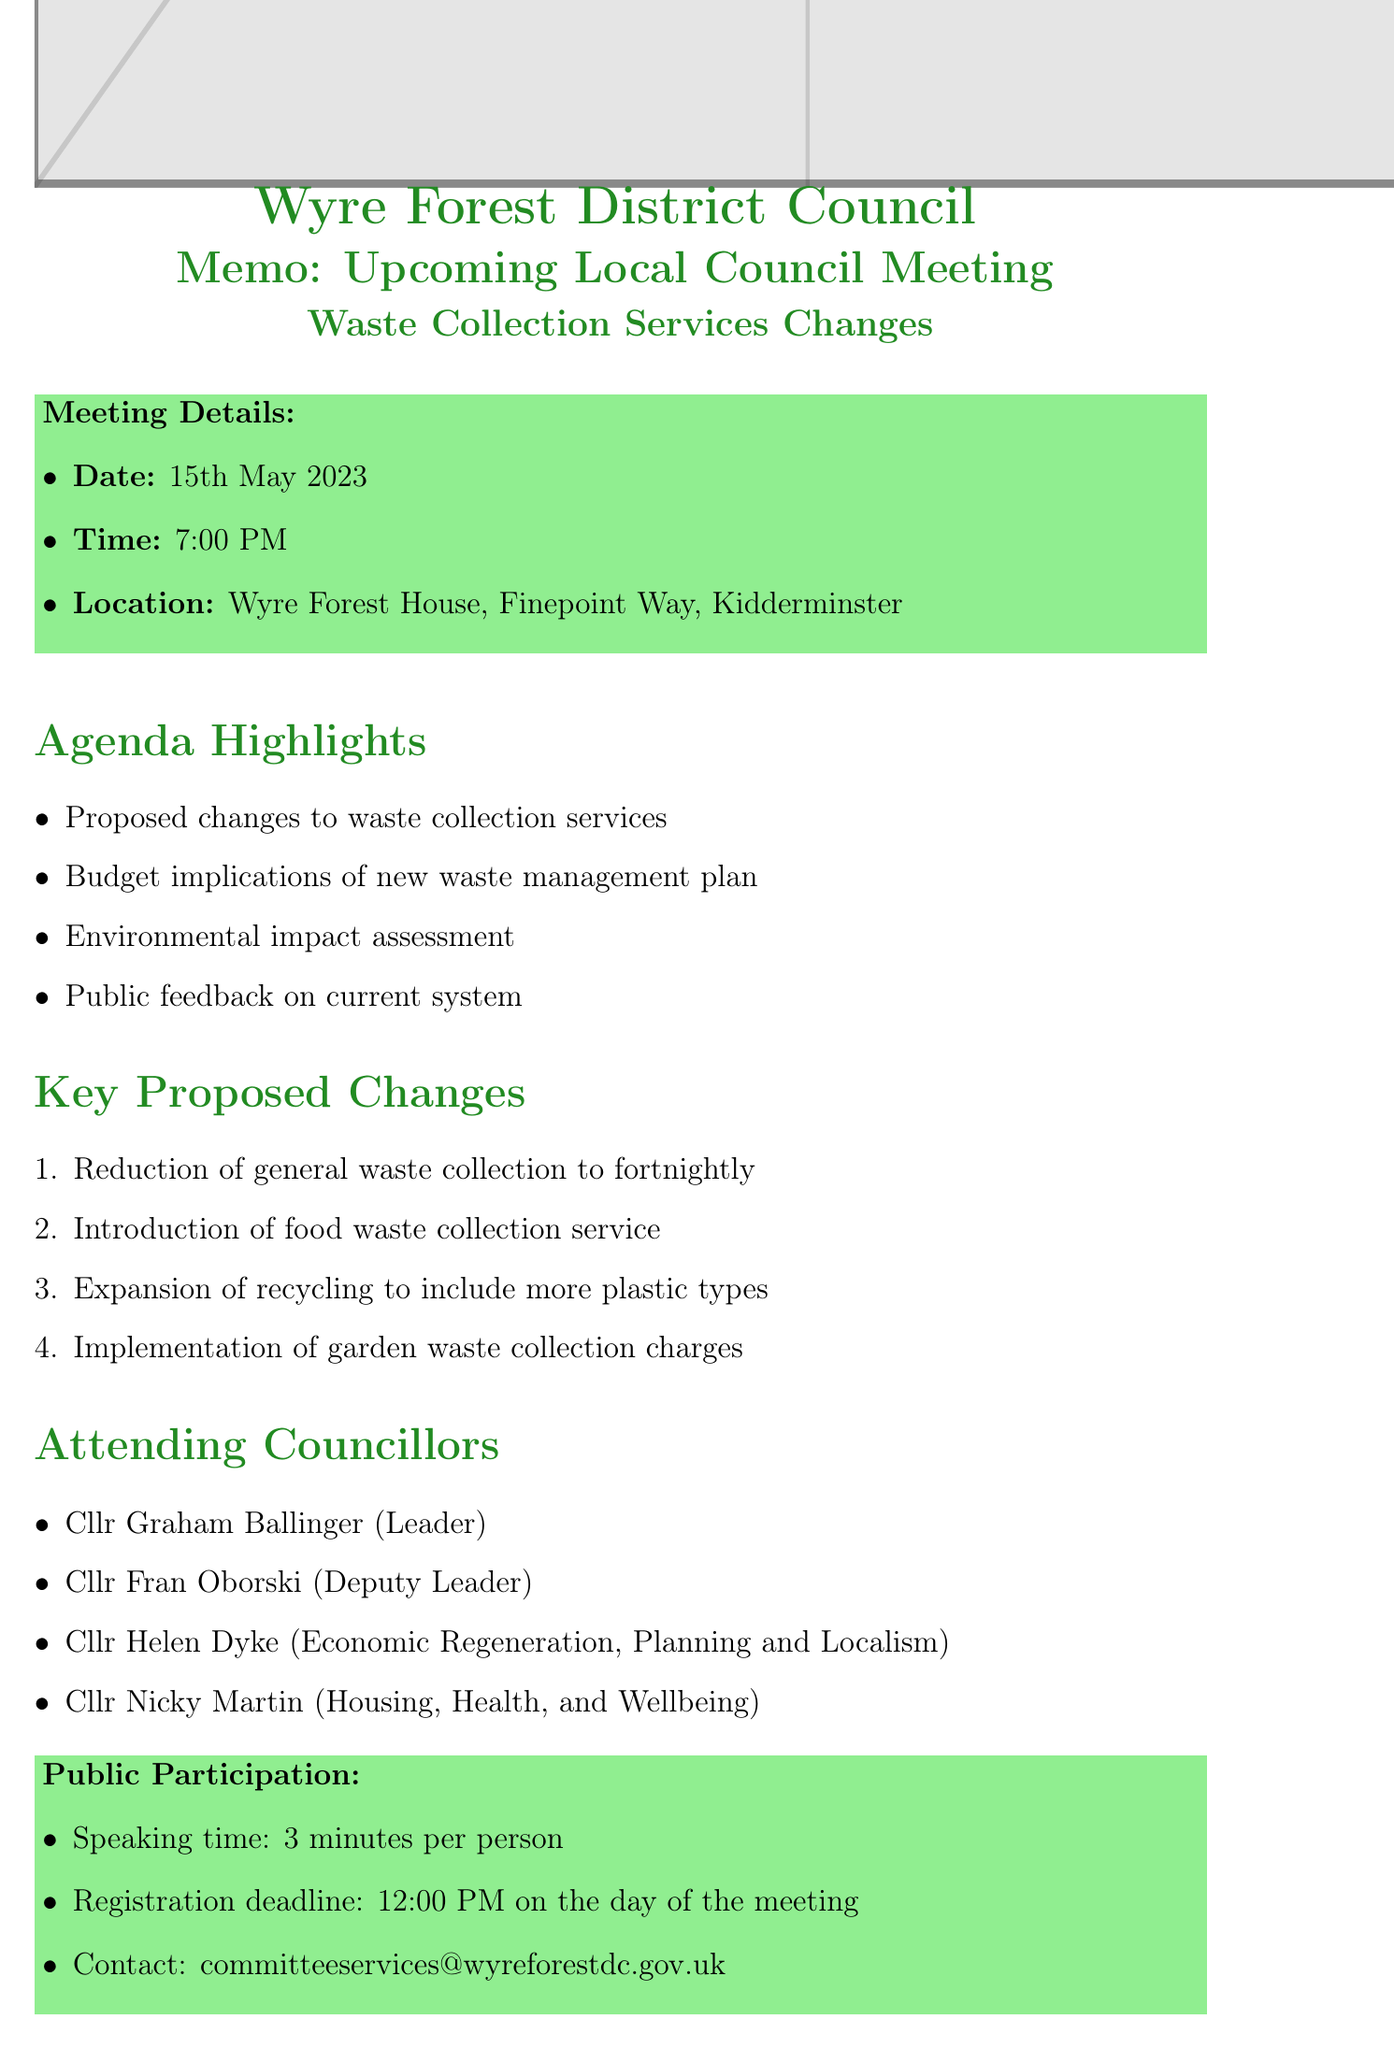What is the date of the meeting? The date of the meeting is given in the document as 15th May 2023.
Answer: 15th May 2023 What are the proposed changes to waste collection services? The document lists specific proposed changes, including the reduction of general waste collection frequency and new services.
Answer: Reduction of general waste collection from weekly to fortnightly, Introduction of food waste collection service, Expansion of recycling collection to include more plastic types, Implementation of garden waste collection charges Who is the Leader of the Council? The document identifies Cllr Graham Ballinger as the Leader of the Council.
Answer: Cllr Graham Ballinger What is the speaking time allowed during public participation? The document specifies that each speaker is allowed 3 minutes to speak during public participation.
Answer: 3 minutes What is the registration deadline for public participation? The deadline for registration is mentioned clearly in the text.
Answer: 12:00 PM on the day of the meeting What is a potential impact on residents from the proposed changes? The document discusses potential adjustments for residents regarding waste collection schedules.
Answer: Adjustment to new collection schedules and possible additional costs for garden waste Which local environmental group is mentioned? The document references specific local environmental groups, one of which is straightforwardly stated.
Answer: Wyre Forest Friends of the Earth 